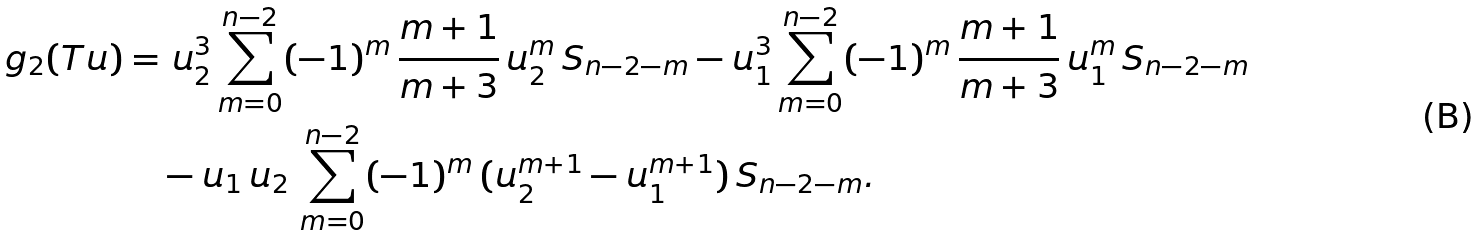Convert formula to latex. <formula><loc_0><loc_0><loc_500><loc_500>g _ { 2 } ( T u ) = & \ u _ { 2 } ^ { 3 } \sum _ { m = 0 } ^ { n - 2 } ( - 1 ) ^ { m } \, \frac { m + 1 } { m + 3 } \, u _ { 2 } ^ { m } \, S _ { n - 2 - m } - u _ { 1 } ^ { 3 } \sum _ { m = 0 } ^ { n - 2 } ( - 1 ) ^ { m } \, \frac { m + 1 } { m + 3 } \, u _ { 1 } ^ { m } \, S _ { n - 2 - m } \\ & - u _ { 1 } \, u _ { 2 } \, \sum _ { m = 0 } ^ { n - 2 } ( - 1 ) ^ { m } \, ( u _ { 2 } ^ { m + 1 } - u _ { 1 } ^ { m + 1 } ) \, S _ { n - 2 - m } .</formula> 